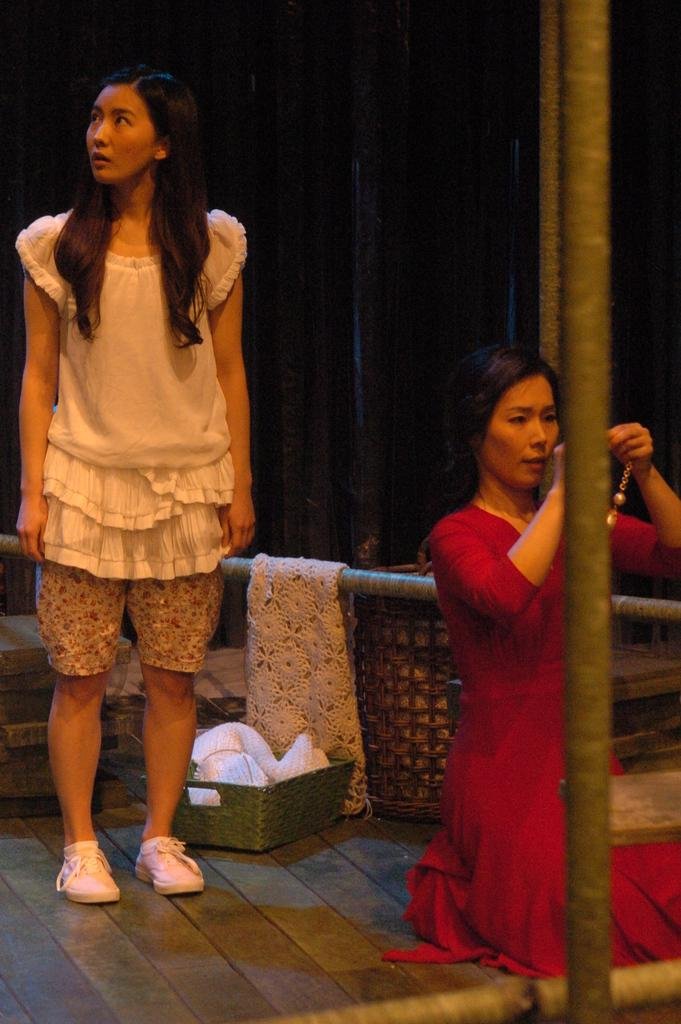How many women are in the image? There are two women in the image. What is one of the women holding in her hands? One of the women is holding something in her hands. What type of items can be seen in the image? Clothes and poles are visible in the image, as well as other objects on the floor. Can you see any toys on the hill in the image? There is no hill or toys present in the image. 